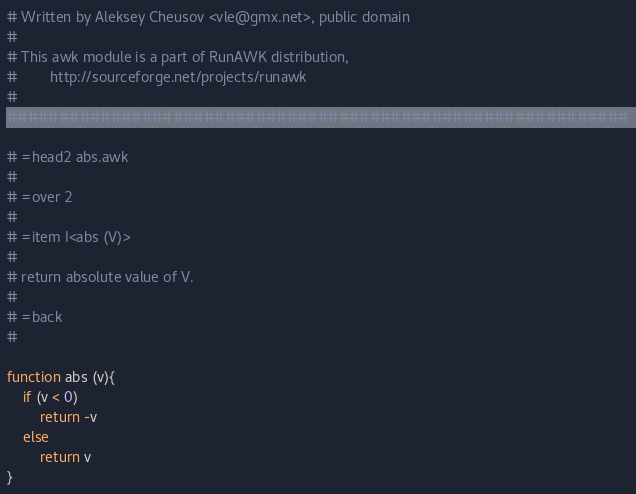Convert code to text. <code><loc_0><loc_0><loc_500><loc_500><_Awk_># Written by Aleksey Cheusov <vle@gmx.net>, public domain
#
# This awk module is a part of RunAWK distribution,
#        http://sourceforge.net/projects/runawk
#    
############################################################

# =head2 abs.awk
#
# =over 2
#
# =item I<abs (V)>
#
# return absolute value of V.
#
# =back
#

function abs (v){
	if (v < 0)
		return -v
	else
		return v
}
</code> 